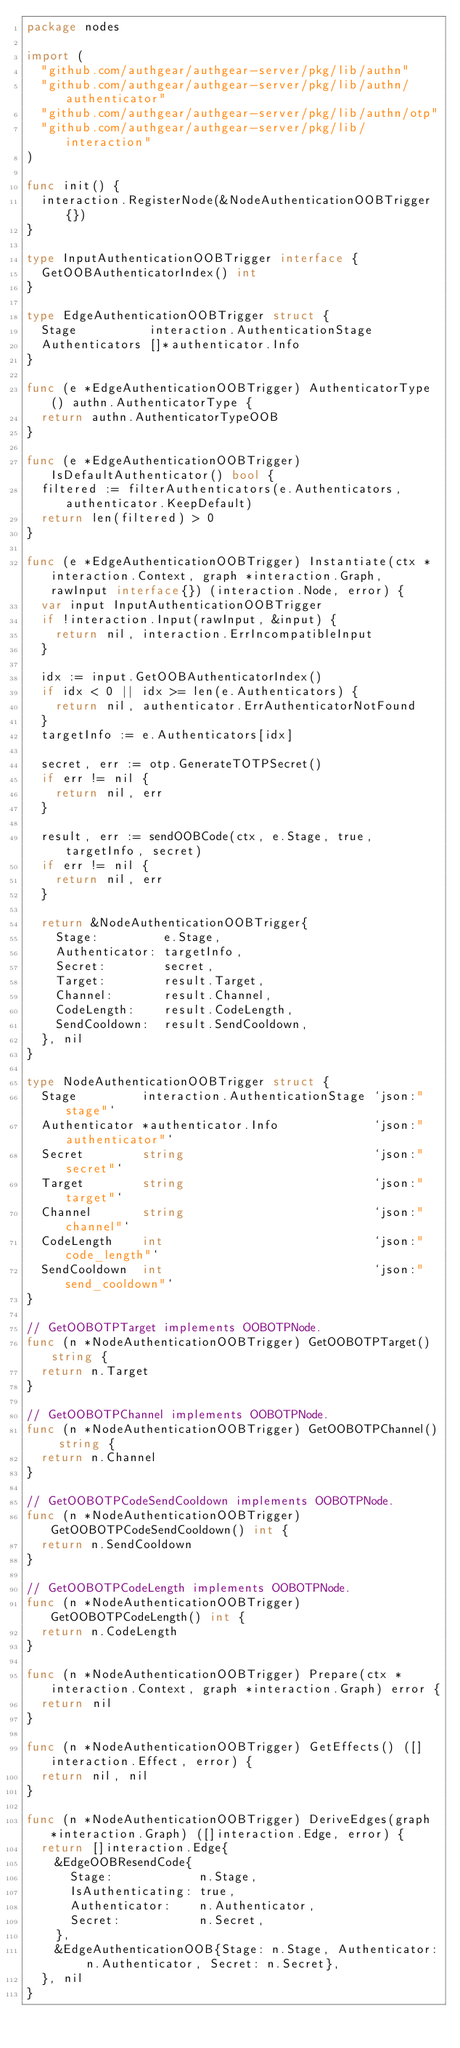Convert code to text. <code><loc_0><loc_0><loc_500><loc_500><_Go_>package nodes

import (
	"github.com/authgear/authgear-server/pkg/lib/authn"
	"github.com/authgear/authgear-server/pkg/lib/authn/authenticator"
	"github.com/authgear/authgear-server/pkg/lib/authn/otp"
	"github.com/authgear/authgear-server/pkg/lib/interaction"
)

func init() {
	interaction.RegisterNode(&NodeAuthenticationOOBTrigger{})
}

type InputAuthenticationOOBTrigger interface {
	GetOOBAuthenticatorIndex() int
}

type EdgeAuthenticationOOBTrigger struct {
	Stage          interaction.AuthenticationStage
	Authenticators []*authenticator.Info
}

func (e *EdgeAuthenticationOOBTrigger) AuthenticatorType() authn.AuthenticatorType {
	return authn.AuthenticatorTypeOOB
}

func (e *EdgeAuthenticationOOBTrigger) IsDefaultAuthenticator() bool {
	filtered := filterAuthenticators(e.Authenticators, authenticator.KeepDefault)
	return len(filtered) > 0
}

func (e *EdgeAuthenticationOOBTrigger) Instantiate(ctx *interaction.Context, graph *interaction.Graph, rawInput interface{}) (interaction.Node, error) {
	var input InputAuthenticationOOBTrigger
	if !interaction.Input(rawInput, &input) {
		return nil, interaction.ErrIncompatibleInput
	}

	idx := input.GetOOBAuthenticatorIndex()
	if idx < 0 || idx >= len(e.Authenticators) {
		return nil, authenticator.ErrAuthenticatorNotFound
	}
	targetInfo := e.Authenticators[idx]

	secret, err := otp.GenerateTOTPSecret()
	if err != nil {
		return nil, err
	}

	result, err := sendOOBCode(ctx, e.Stage, true, targetInfo, secret)
	if err != nil {
		return nil, err
	}

	return &NodeAuthenticationOOBTrigger{
		Stage:         e.Stage,
		Authenticator: targetInfo,
		Secret:        secret,
		Target:        result.Target,
		Channel:       result.Channel,
		CodeLength:    result.CodeLength,
		SendCooldown:  result.SendCooldown,
	}, nil
}

type NodeAuthenticationOOBTrigger struct {
	Stage         interaction.AuthenticationStage `json:"stage"`
	Authenticator *authenticator.Info             `json:"authenticator"`
	Secret        string                          `json:"secret"`
	Target        string                          `json:"target"`
	Channel       string                          `json:"channel"`
	CodeLength    int                             `json:"code_length"`
	SendCooldown  int                             `json:"send_cooldown"`
}

// GetOOBOTPTarget implements OOBOTPNode.
func (n *NodeAuthenticationOOBTrigger) GetOOBOTPTarget() string {
	return n.Target
}

// GetOOBOTPChannel implements OOBOTPNode.
func (n *NodeAuthenticationOOBTrigger) GetOOBOTPChannel() string {
	return n.Channel
}

// GetOOBOTPCodeSendCooldown implements OOBOTPNode.
func (n *NodeAuthenticationOOBTrigger) GetOOBOTPCodeSendCooldown() int {
	return n.SendCooldown
}

// GetOOBOTPCodeLength implements OOBOTPNode.
func (n *NodeAuthenticationOOBTrigger) GetOOBOTPCodeLength() int {
	return n.CodeLength
}

func (n *NodeAuthenticationOOBTrigger) Prepare(ctx *interaction.Context, graph *interaction.Graph) error {
	return nil
}

func (n *NodeAuthenticationOOBTrigger) GetEffects() ([]interaction.Effect, error) {
	return nil, nil
}

func (n *NodeAuthenticationOOBTrigger) DeriveEdges(graph *interaction.Graph) ([]interaction.Edge, error) {
	return []interaction.Edge{
		&EdgeOOBResendCode{
			Stage:            n.Stage,
			IsAuthenticating: true,
			Authenticator:    n.Authenticator,
			Secret:           n.Secret,
		},
		&EdgeAuthenticationOOB{Stage: n.Stage, Authenticator: n.Authenticator, Secret: n.Secret},
	}, nil
}
</code> 